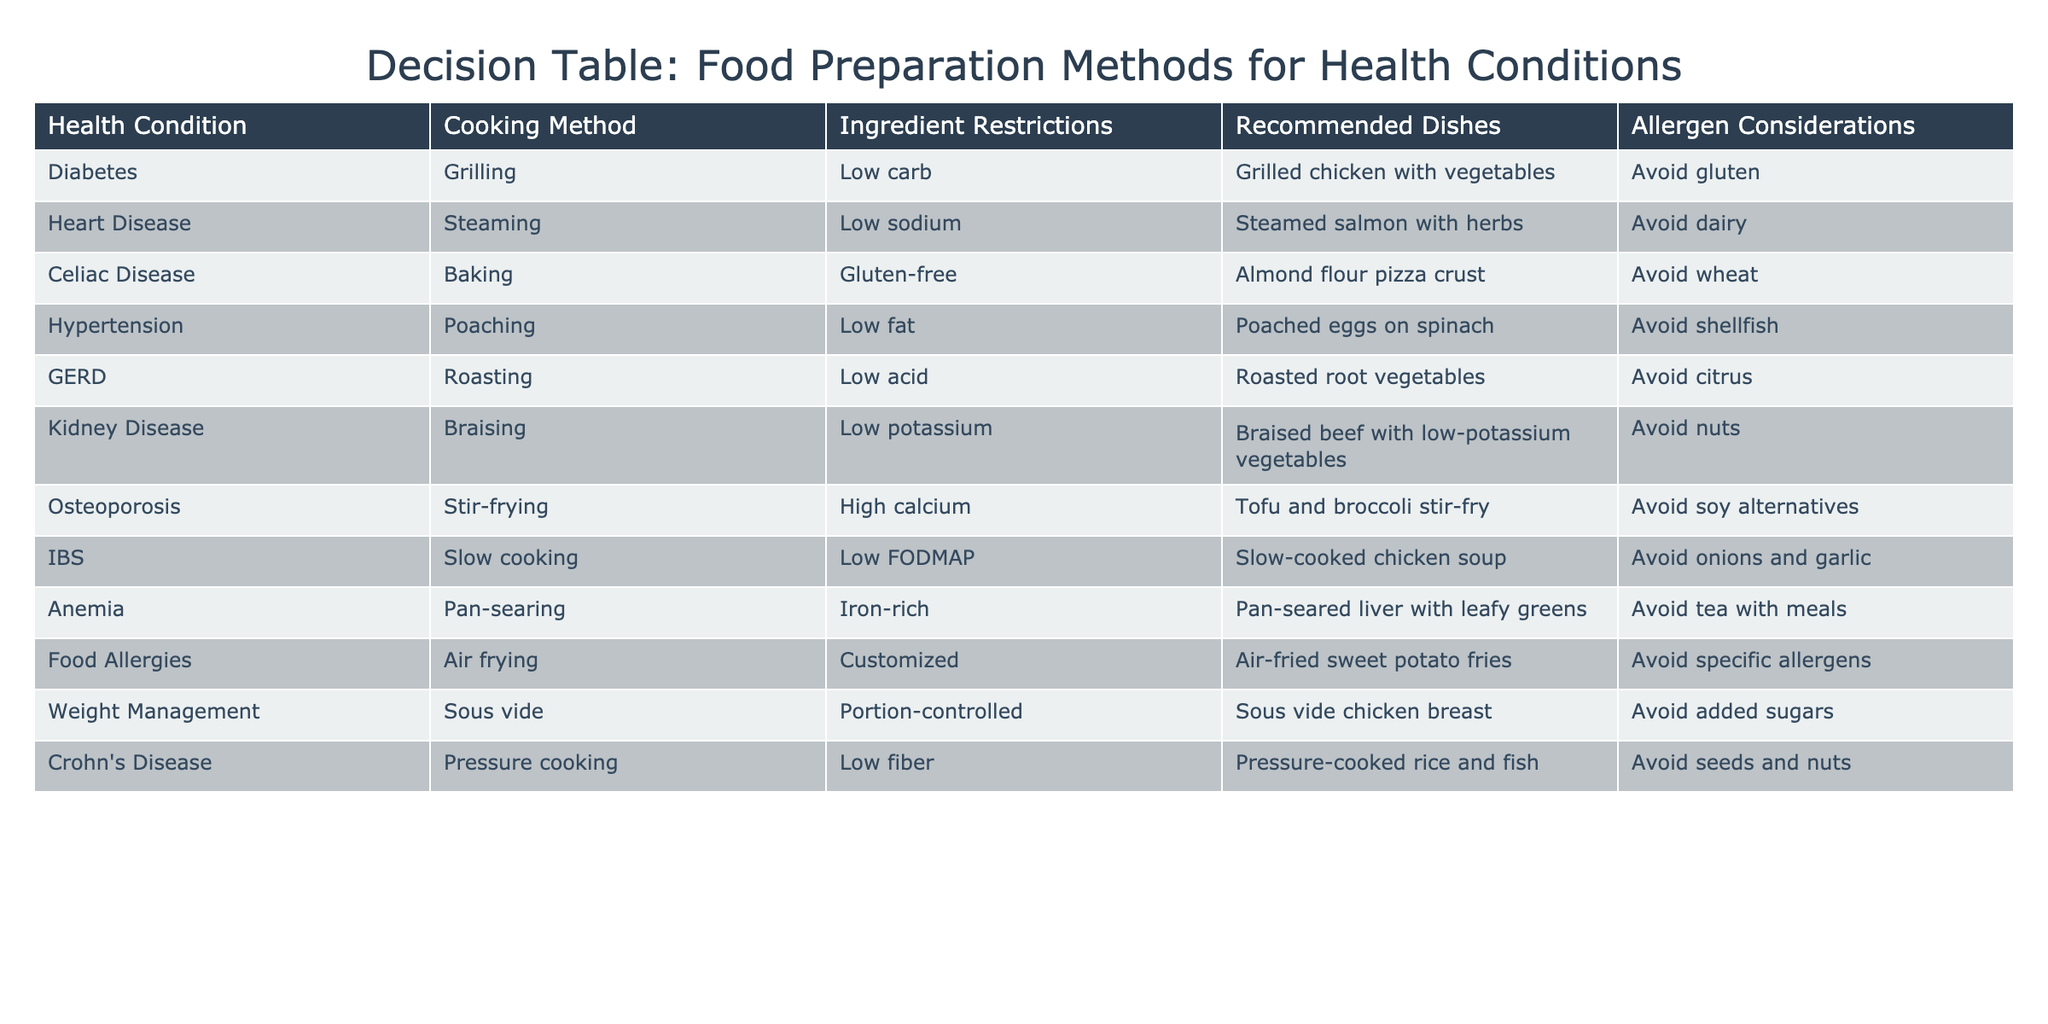What cooking method is recommended for diabetes? The table lists 'Grilling' as the recommended cooking method for diabetes.
Answer: Grilling Which dish is suggested for a person with heart disease? The table indicates 'Steamed salmon with herbs' as the suggested dish for heart disease.
Answer: Steamed salmon with herbs Are low-carb ingredients advised for those with hypertension? According to the table, the cooking method for hypertension is 'Poaching', and it recommends 'Low fat'. There is no direct mention of low-carb ingredients being necessary for hypertension.
Answer: No What is the ingredient restriction for celiac disease? The table states that the ingredient restriction for celiac disease is 'Gluten-free'.
Answer: Gluten-free How many cooking methods in the table require avoiding nuts? The rows for kidney disease and Crohn's disease both require avoiding nuts, meaning there are 2 cooking methods that specify this restriction.
Answer: 2 Is sous vide recommended for weight management? The table confirms that 'Sous vide' is indeed recommended for weight management by presenting it as the suitable cooking method for that condition.
Answer: Yes What dish is recommended for someone with IBS? The table provides 'Slow-cooked chicken soup' as the recommended dish for someone with IBS.
Answer: Slow-cooked chicken soup Which cooking methods are recommended for both anemia and osteoporosis? Anemia recommends 'Pan-searing' while osteoporosis suggests 'Stir-frying'. Both cooking methods serve different conditions, thus not sharing the same method.
Answer: None If a person is avoiding added sugars, which cooking method should they choose? The table indicates that with an aim to avoid added sugars, they should choose the 'Sous vide' method, which is explicitly tailored for this need under weight management.
Answer: Sous vide What allergies should be considered when air frying? The table states that when air frying, specific allergens must be avoided, indicating a need for customization based on personal allergies.
Answer: Specific allergens 